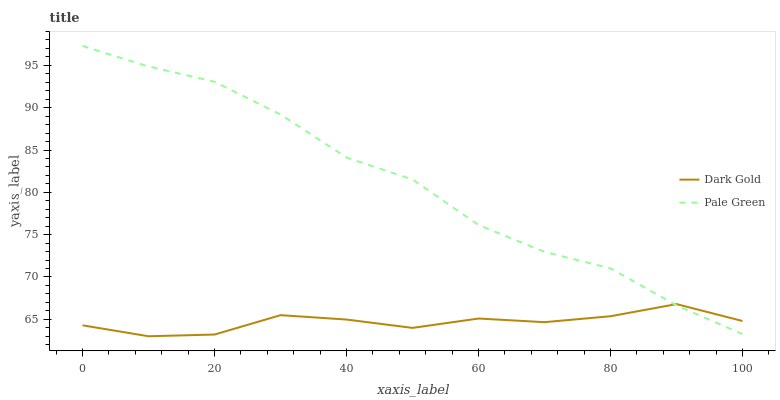Does Dark Gold have the maximum area under the curve?
Answer yes or no. No. Is Dark Gold the roughest?
Answer yes or no. No. Does Dark Gold have the highest value?
Answer yes or no. No. 